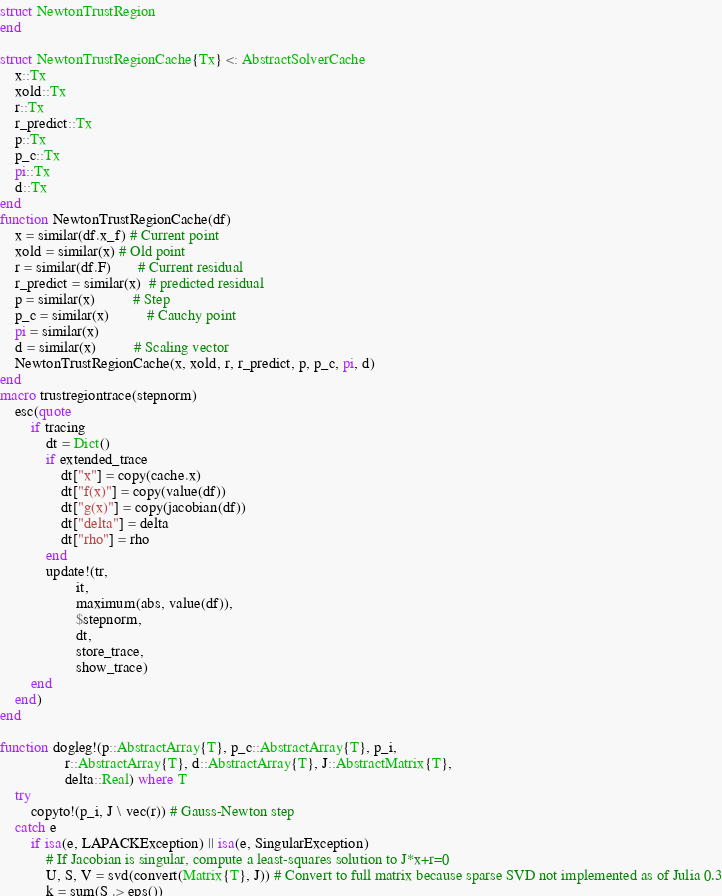Convert code to text. <code><loc_0><loc_0><loc_500><loc_500><_Julia_>struct NewtonTrustRegion
end

struct NewtonTrustRegionCache{Tx} <: AbstractSolverCache
    x::Tx
    xold::Tx
    r::Tx
    r_predict::Tx
    p::Tx
    p_c::Tx
    pi::Tx
    d::Tx
end
function NewtonTrustRegionCache(df)
    x = similar(df.x_f) # Current point
    xold = similar(x) # Old point
    r = similar(df.F)       # Current residual
    r_predict = similar(x)  # predicted residual
    p = similar(x)          # Step
    p_c = similar(x)          # Cauchy point
    pi = similar(x)
    d = similar(x)          # Scaling vector
    NewtonTrustRegionCache(x, xold, r, r_predict, p, p_c, pi, d)
end
macro trustregiontrace(stepnorm)
    esc(quote
        if tracing
            dt = Dict()
            if extended_trace
                dt["x"] = copy(cache.x)
                dt["f(x)"] = copy(value(df))
                dt["g(x)"] = copy(jacobian(df))
                dt["delta"] = delta
                dt["rho"] = rho
            end
            update!(tr,
                    it,
                    maximum(abs, value(df)),
                    $stepnorm,
                    dt,
                    store_trace,
                    show_trace)
        end
    end)
end

function dogleg!(p::AbstractArray{T}, p_c::AbstractArray{T}, p_i,
                 r::AbstractArray{T}, d::AbstractArray{T}, J::AbstractMatrix{T},
                 delta::Real) where T
    try
        copyto!(p_i, J \ vec(r)) # Gauss-Newton step
    catch e
        if isa(e, LAPACKException) || isa(e, SingularException)
            # If Jacobian is singular, compute a least-squares solution to J*x+r=0
            U, S, V = svd(convert(Matrix{T}, J)) # Convert to full matrix because sparse SVD not implemented as of Julia 0.3
            k = sum(S .> eps())</code> 